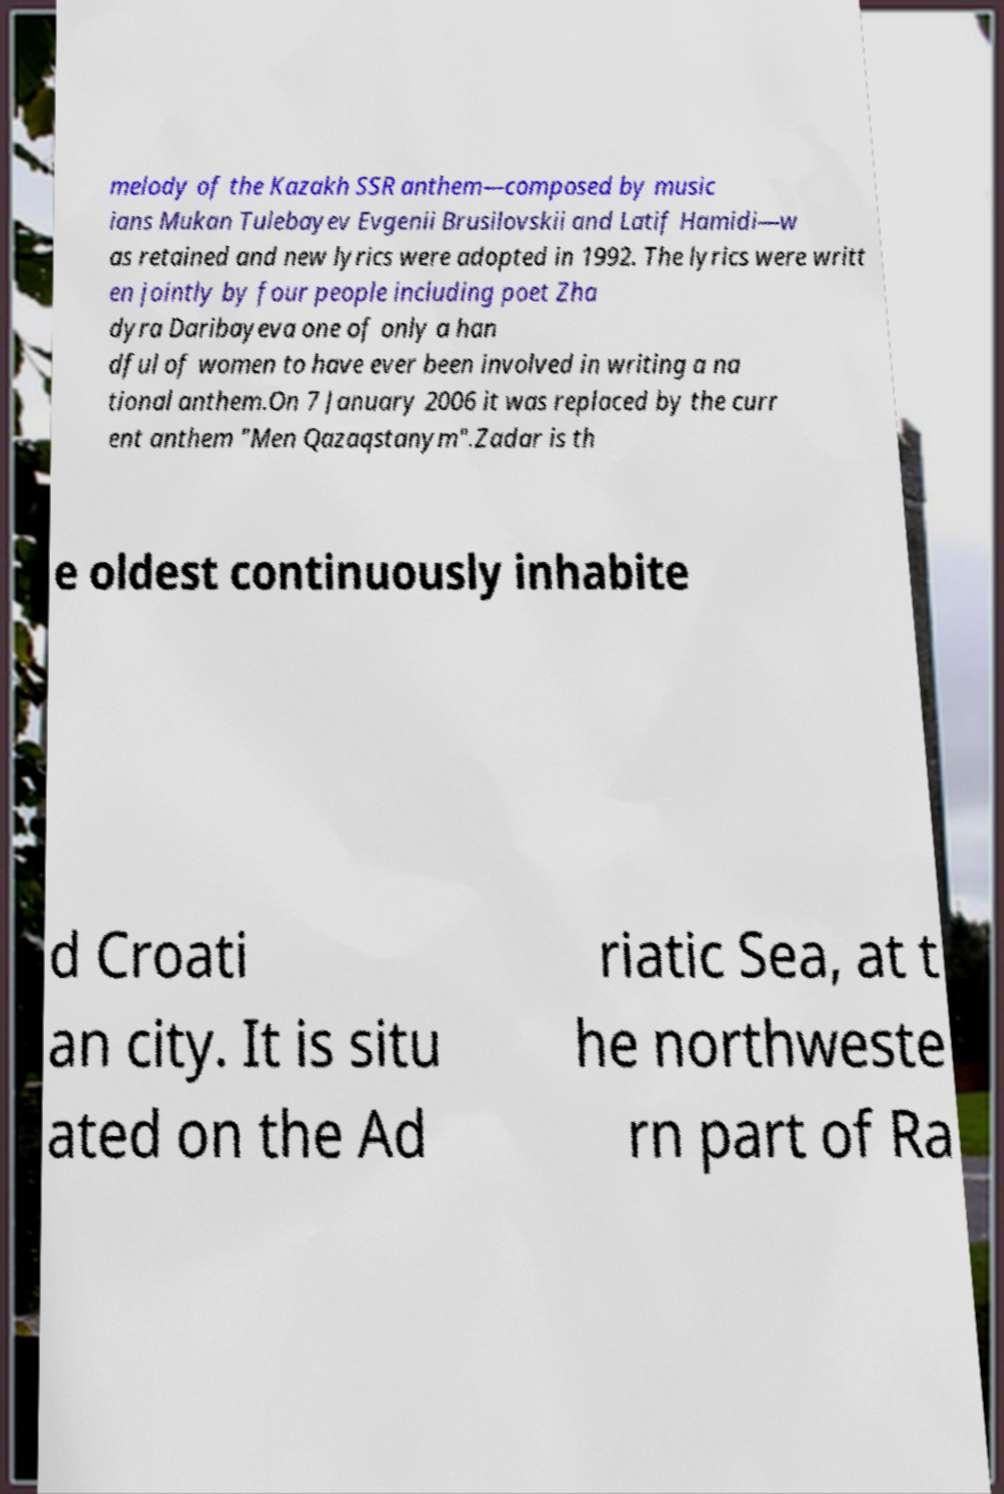Please read and relay the text visible in this image. What does it say? melody of the Kazakh SSR anthem—composed by music ians Mukan Tulebayev Evgenii Brusilovskii and Latif Hamidi—w as retained and new lyrics were adopted in 1992. The lyrics were writt en jointly by four people including poet Zha dyra Daribayeva one of only a han dful of women to have ever been involved in writing a na tional anthem.On 7 January 2006 it was replaced by the curr ent anthem "Men Qazaqstanym".Zadar is th e oldest continuously inhabite d Croati an city. It is situ ated on the Ad riatic Sea, at t he northweste rn part of Ra 